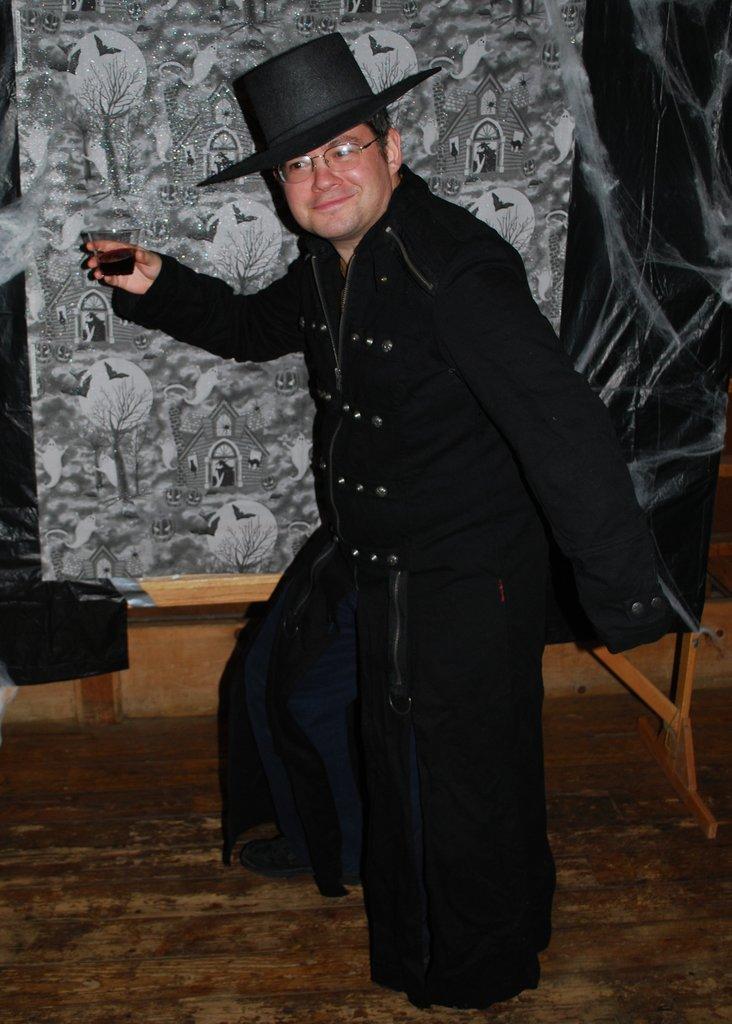In one or two sentences, can you explain what this image depicts? In this image, we can see a person wearing a cap is holding an object and standing. We can see the ground. We can see a poster with some images. We can also see a black colored object and some wood. 